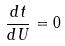Convert formula to latex. <formula><loc_0><loc_0><loc_500><loc_500>\frac { d t } { d U } = 0</formula> 